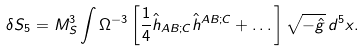Convert formula to latex. <formula><loc_0><loc_0><loc_500><loc_500>\delta S _ { 5 } = M _ { S } ^ { 3 } \int \Omega ^ { - 3 } \left [ \frac { 1 } { 4 } \hat { h } _ { A B ; C } \hat { h } ^ { A B ; C } + \dots \right ] \sqrt { - \hat { g } } \, d ^ { 5 } x .</formula> 